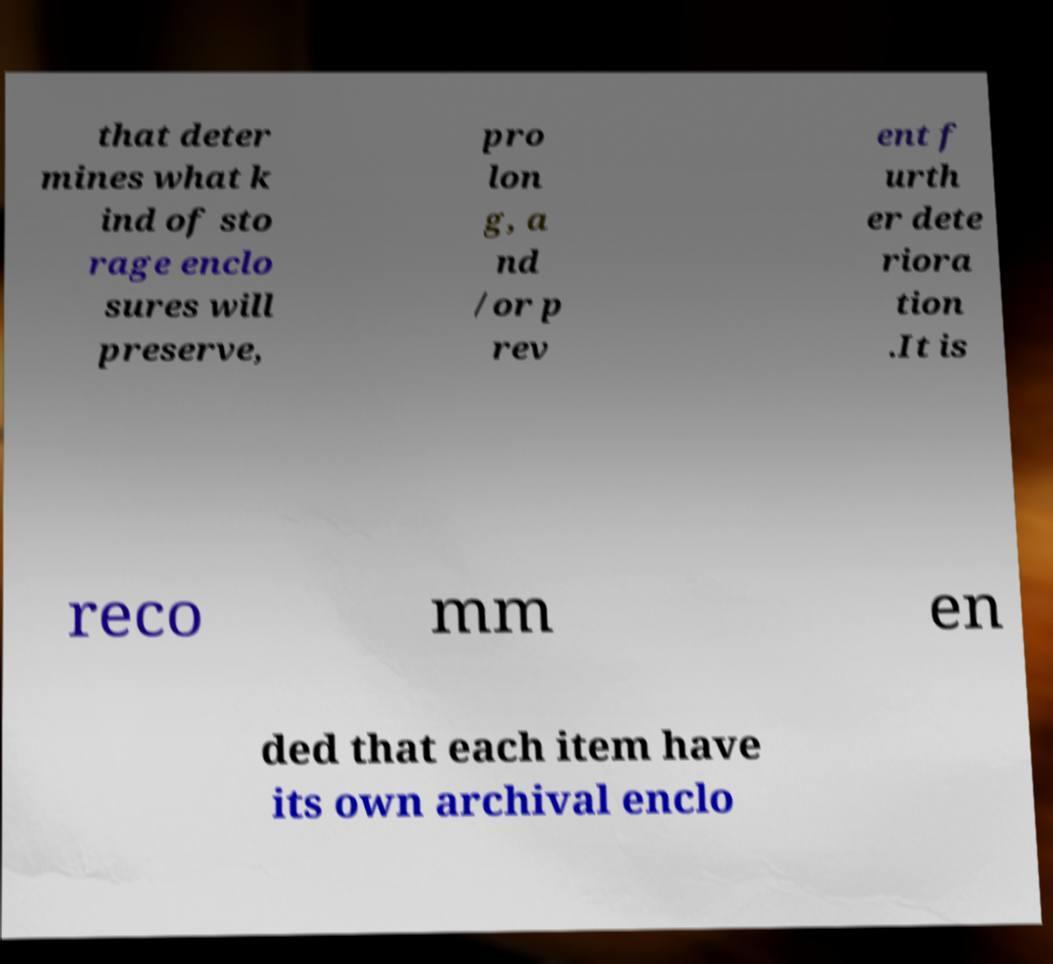Please read and relay the text visible in this image. What does it say? that deter mines what k ind of sto rage enclo sures will preserve, pro lon g, a nd /or p rev ent f urth er dete riora tion .It is reco mm en ded that each item have its own archival enclo 